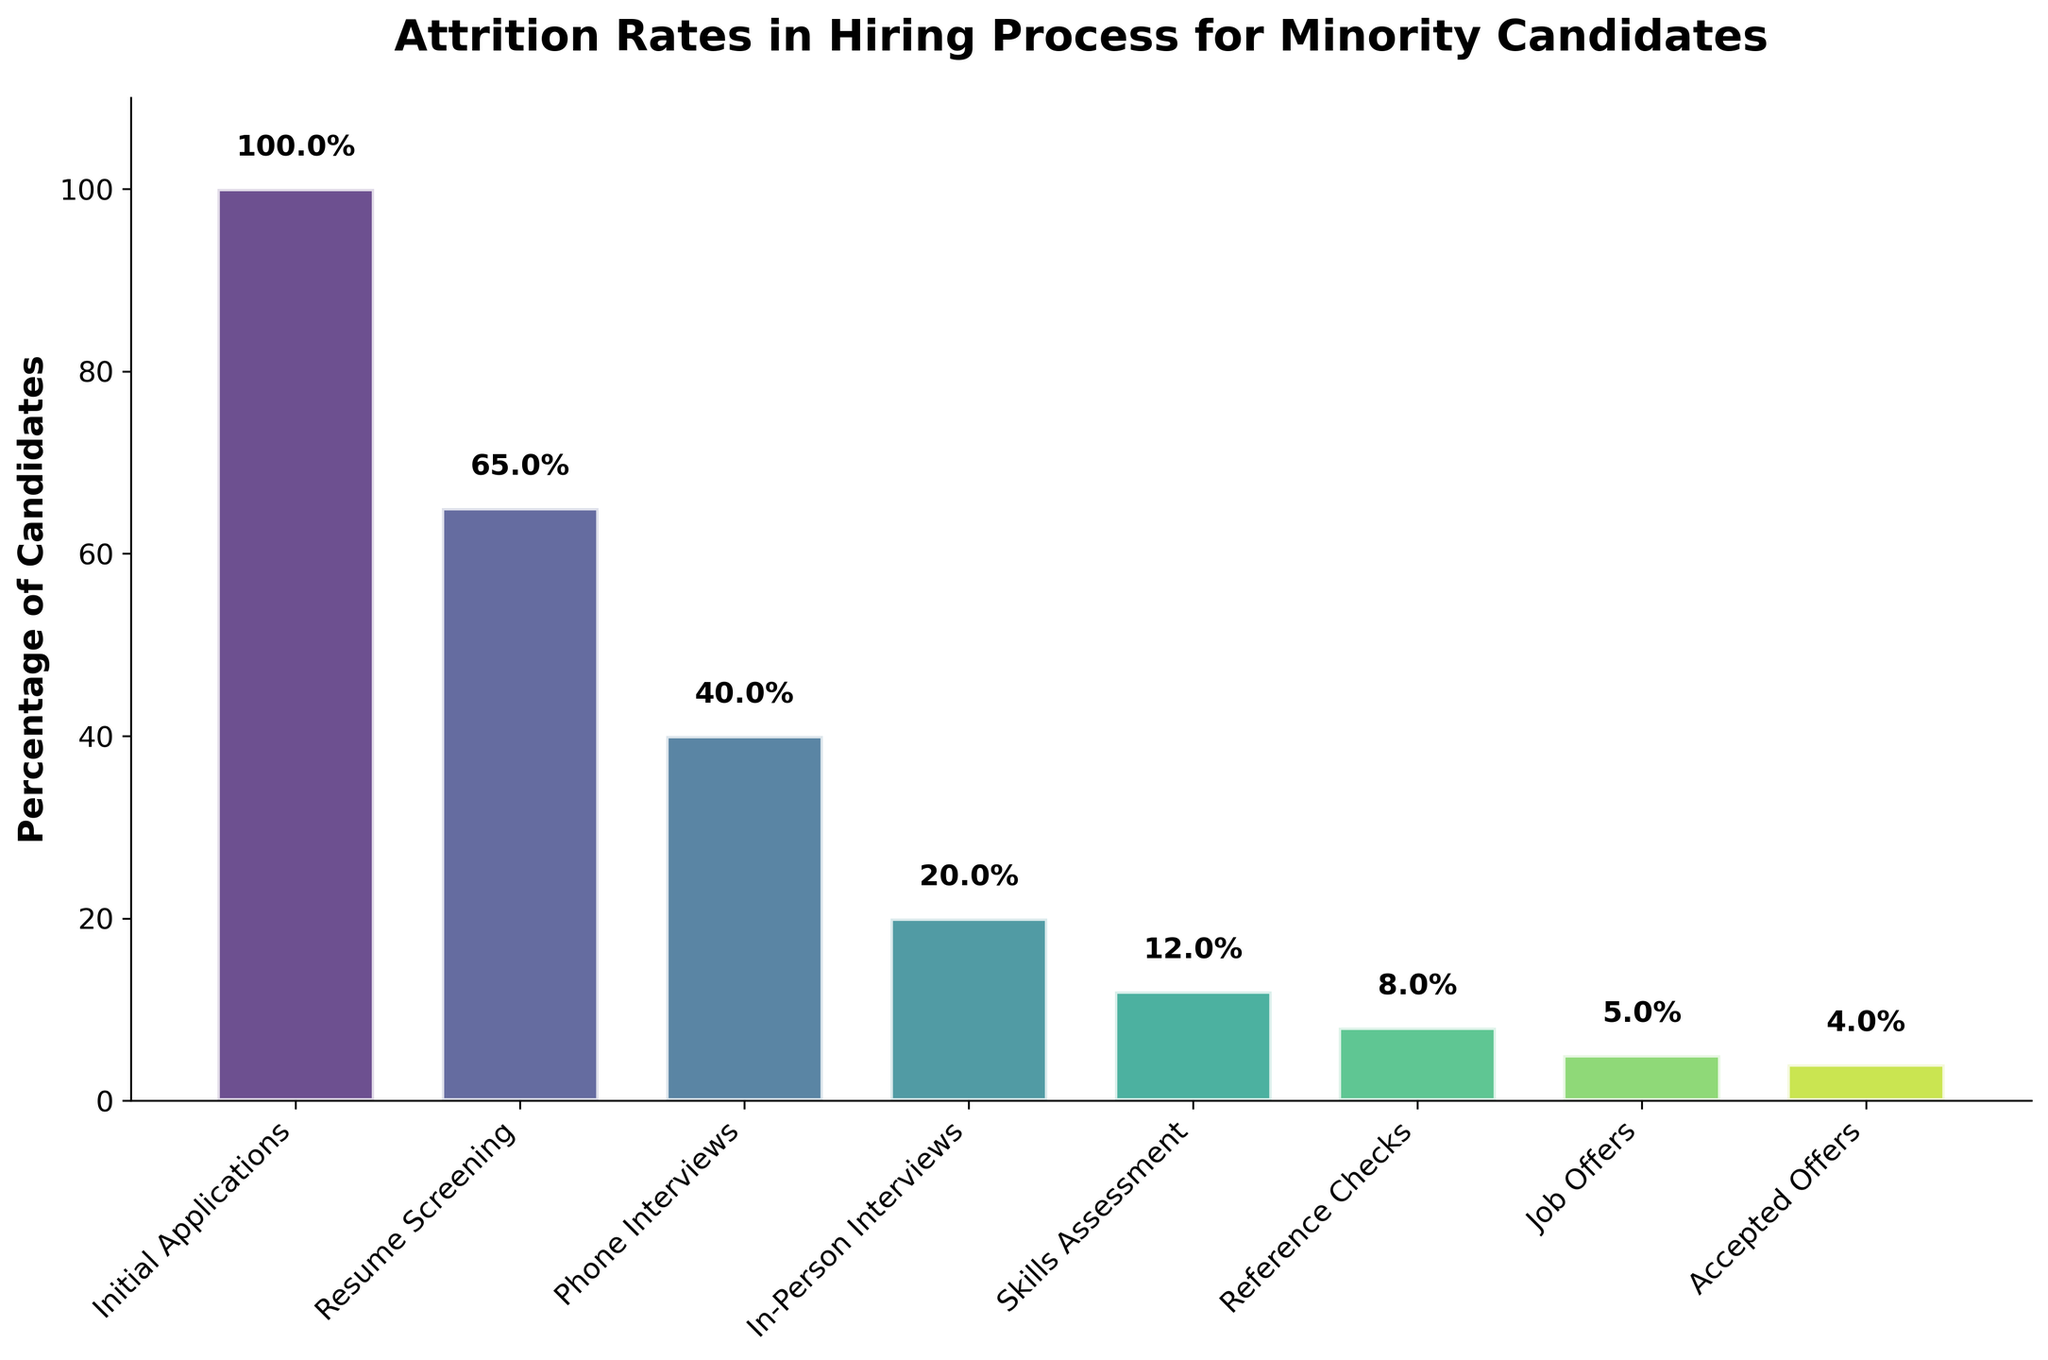What is the title of the plot? The title of the plot is usually found at the top, in larger and bolder text. In this case, the title reads 'Attrition Rates in Hiring Process for Minority Candidates'.
Answer: Attrition Rates in Hiring Process for Minority Candidates How many steps are shown in the hiring process on this chart? Count the number of unique steps listed along the x-axis of the funnel chart. Each step represents a stage in the hiring process. There are eight steps shown from 'Initial Applications' to 'Accepted Offers'.
Answer: Eight What is the percentage of candidates that passed the Phone Interviews stage? Look at the bar labeled 'Phone Interviews' and read the percentage value placed above or within the bar. The value indicates the percentage of candidates that passed that stage.
Answer: 40% How does the attrition rate change between Resume Screening and Phone Interviews? Identify the percentage values for 'Resume Screening' (65%) and 'Phone Interviews' (40%). Calculate the difference to determine the change in attrition rate.
Answer: It decreases by 25% What step has the largest drop in the percentage of candidates from the previous step? Compare the percentage decline between consecutive steps to identify the largest drop. Subtract each step's percentage from the previous one and identify the step with the highest difference. From 'Phone Interviews' (40%) to 'In-Person Interviews' (20%) drops by 20%, which is the largest.
Answer: In-Person Interviews What percentage of candidates who went through Skills Assessment actually received Job Offers? Identify the percentage of candidates at the 'Skills Assessment' stage (12%) and those at the 'Job Offers' stage (5%). Then, compare these two percentages.
Answer: 5% What is the overall acceptance rate of job offers based on this funnel chart? Find the percentage of 'Accepted Offers' (4%) and compare it to the initial number of candidates (100% at 'Initial Applications').
Answer: 4% How many more candidates made it through the Resume Screening compared to the In-Person Interviews? Identify the number of candidates for both stages: Resume Screening (650 candidates) and In-Person Interviews (200 candidates). Subtract the number of candidates at 'In-Person Interviews' from 'Resume Screening'.
Answer: 450 candidates Which step has the fewest candidates left, and what is this number? Look at the values for each step and determine the step with the lowest count of candidates. In this chart, it is 'Accepted Offers' with 40 candidates.
Answer: Accepted Offers, 40 What is the attrition rate between Skills Assessment and Reference Checks? Identify the percentage values for 'Skills Assessment' (12%) and 'Reference Checks' (8%). Subtract the latter from the former to find the attrition rate.
Answer: 4% 